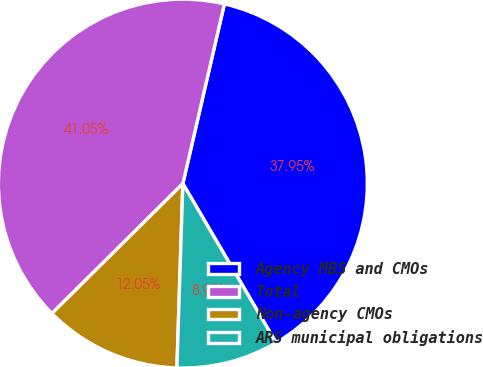Convert chart. <chart><loc_0><loc_0><loc_500><loc_500><pie_chart><fcel>Agency MBS and CMOs<fcel>Total<fcel>Non-agency CMOs<fcel>ARS municipal obligations<nl><fcel>37.95%<fcel>41.05%<fcel>12.05%<fcel>8.95%<nl></chart> 